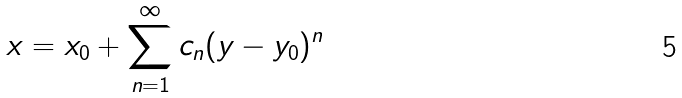Convert formula to latex. <formula><loc_0><loc_0><loc_500><loc_500>x = x _ { 0 } + \sum _ { n = 1 } ^ { \infty } c _ { n } ( y - y _ { 0 } ) ^ { n }</formula> 